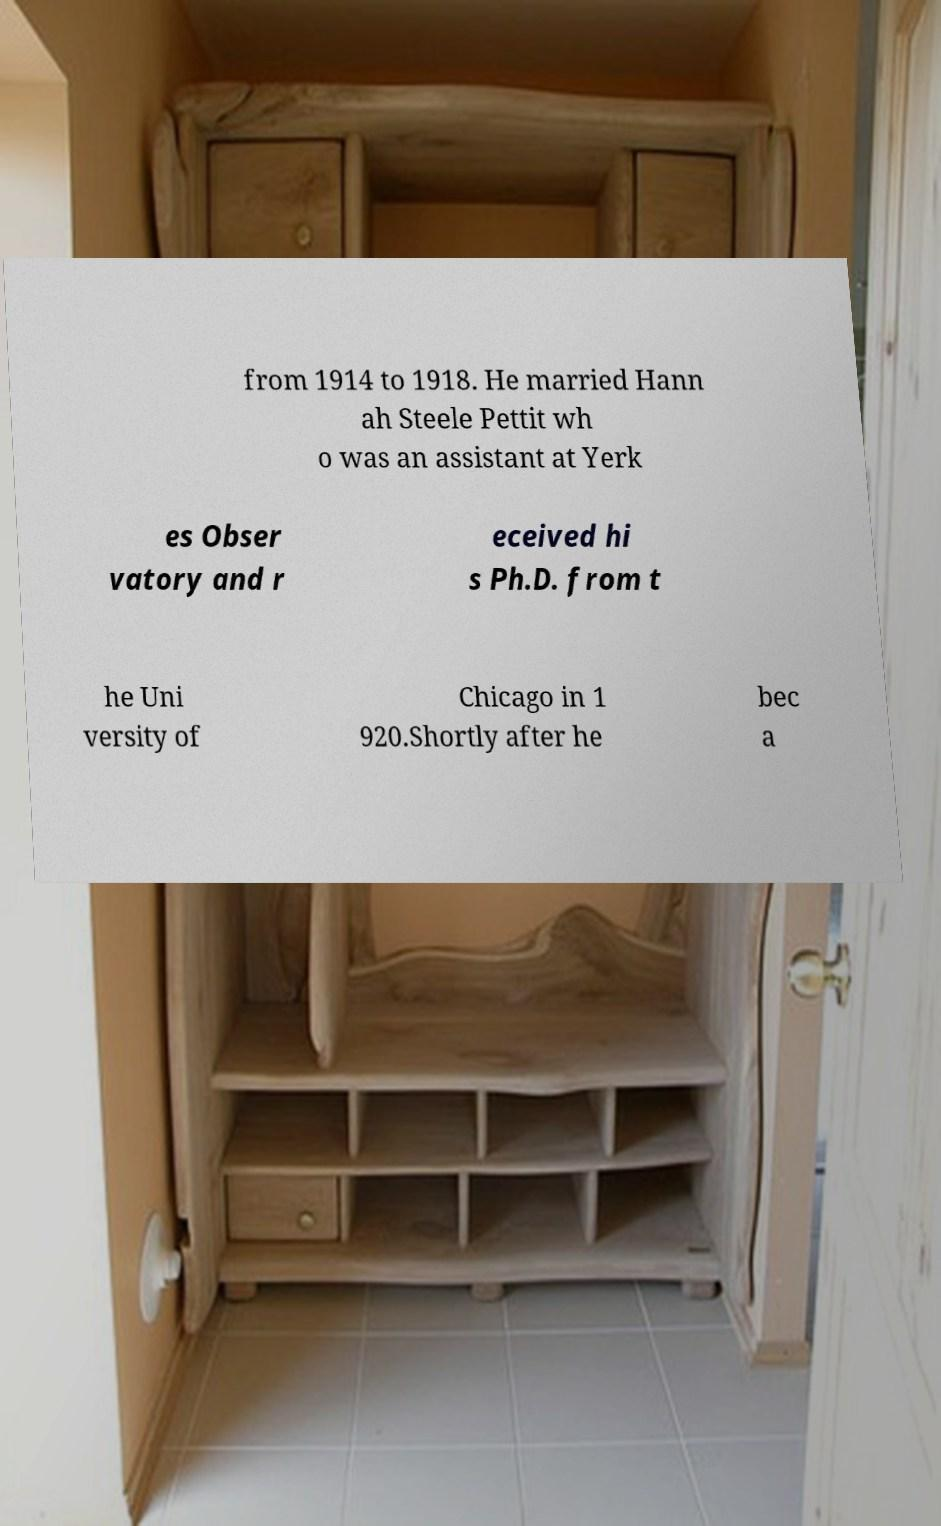Please identify and transcribe the text found in this image. from 1914 to 1918. He married Hann ah Steele Pettit wh o was an assistant at Yerk es Obser vatory and r eceived hi s Ph.D. from t he Uni versity of Chicago in 1 920.Shortly after he bec a 